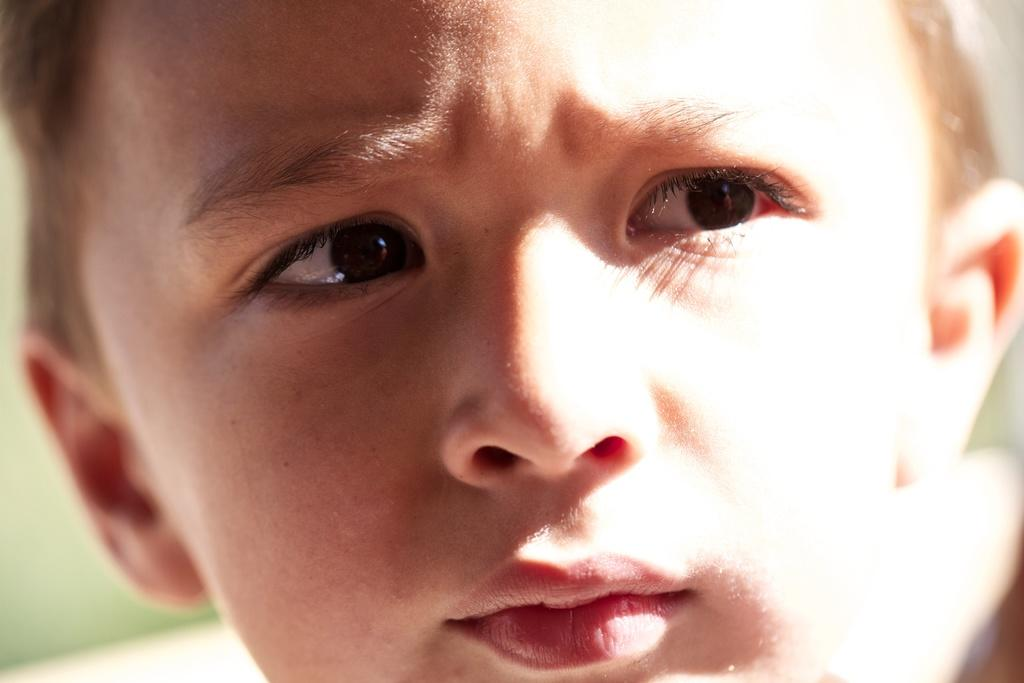What is the main subject of the image? There is a person's face in the image. Can you describe the background of the image? The background of the image is blurred. What type of kitten is being served juice during the battle in the image? There is no kitten, juice, or battle present in the image; it features a person's face with a blurred background. 